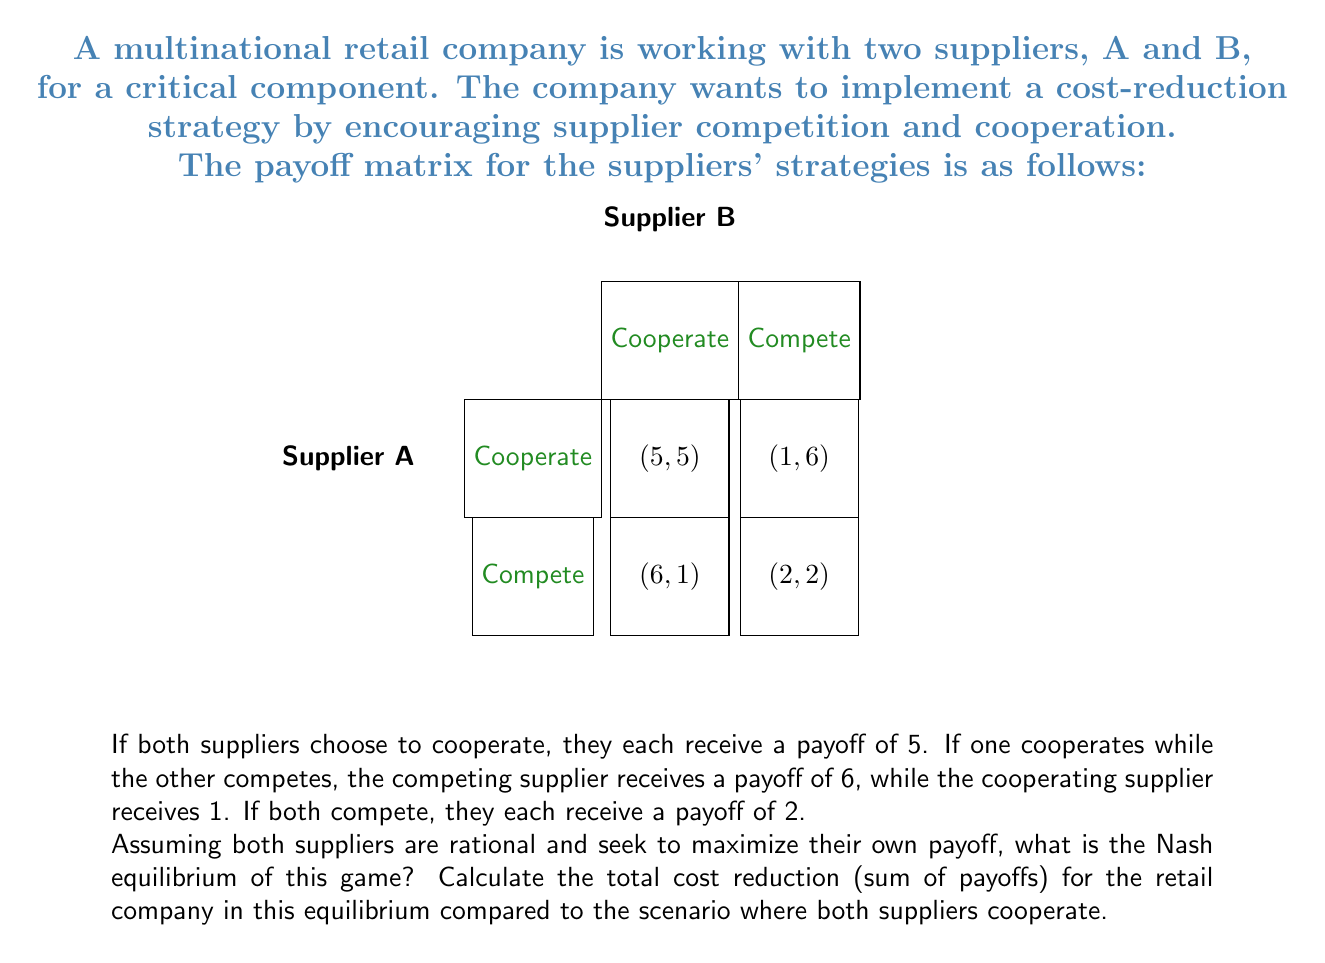Show me your answer to this math problem. To solve this problem, we need to follow these steps:

1. Identify the Nash equilibrium:
   A Nash equilibrium occurs when no player can unilaterally change their strategy to increase their payoff.

   For Supplier A:
   - If B cooperates, A's best response is to compete (6 > 5)
   - If B competes, A's best response is to compete (2 > 1)

   For Supplier B:
   - If A cooperates, B's best response is to compete (6 > 5)
   - If A competes, B's best response is to compete (2 > 1)

   Therefore, the Nash equilibrium is (Compete, Compete), resulting in payoffs of (2, 2).

2. Calculate the total payoff in the Nash equilibrium:
   $$\text{Total payoff}_{\text{Nash}} = 2 + 2 = 4$$

3. Calculate the total payoff if both suppliers cooperate:
   $$\text{Total payoff}_{\text{Cooperate}} = 5 + 5 = 10$$

4. Calculate the difference in total payoffs:
   $$\text{Difference} = \text{Total payoff}_{\text{Cooperate}} - \text{Total payoff}_{\text{Nash}}$$
   $$\text{Difference} = 10 - 4 = 6$$

This difference represents the cost reduction lost due to the competitive behavior in the Nash equilibrium compared to the cooperative scenario.
Answer: Nash equilibrium: (Compete, Compete); Lost cost reduction: 6 